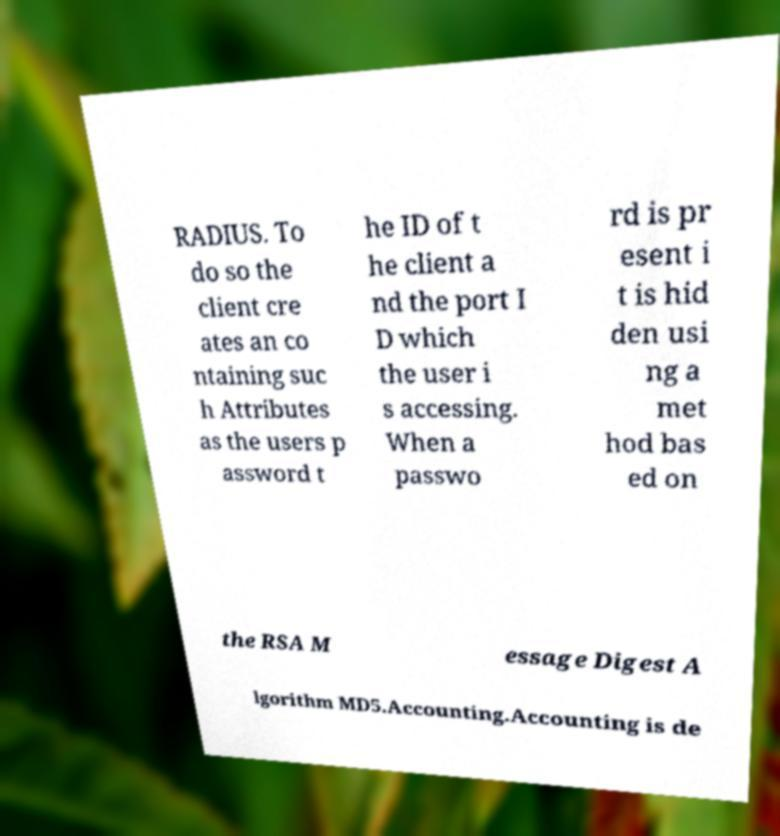There's text embedded in this image that I need extracted. Can you transcribe it verbatim? RADIUS. To do so the client cre ates an co ntaining suc h Attributes as the users p assword t he ID of t he client a nd the port I D which the user i s accessing. When a passwo rd is pr esent i t is hid den usi ng a met hod bas ed on the RSA M essage Digest A lgorithm MD5.Accounting.Accounting is de 